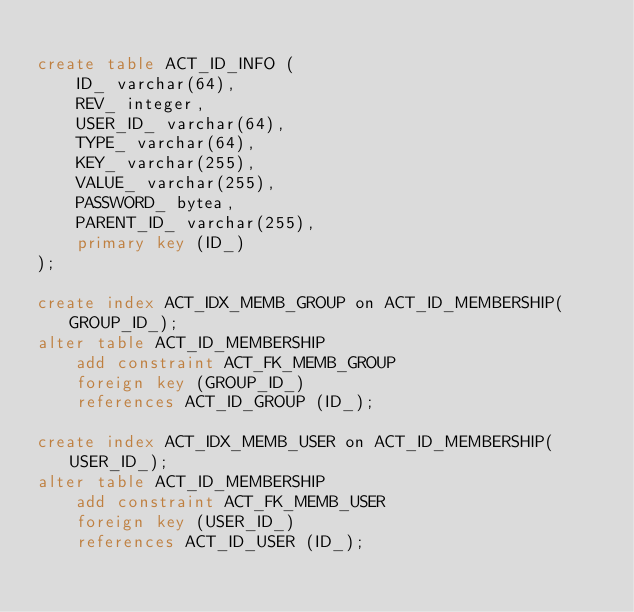Convert code to text. <code><loc_0><loc_0><loc_500><loc_500><_SQL_>
create table ACT_ID_INFO (
    ID_ varchar(64),
    REV_ integer,
    USER_ID_ varchar(64),
    TYPE_ varchar(64),
    KEY_ varchar(255),
    VALUE_ varchar(255),
    PASSWORD_ bytea,
    PARENT_ID_ varchar(255),
    primary key (ID_)
);

create index ACT_IDX_MEMB_GROUP on ACT_ID_MEMBERSHIP(GROUP_ID_);
alter table ACT_ID_MEMBERSHIP 
    add constraint ACT_FK_MEMB_GROUP
    foreign key (GROUP_ID_) 
    references ACT_ID_GROUP (ID_);

create index ACT_IDX_MEMB_USER on ACT_ID_MEMBERSHIP(USER_ID_);
alter table ACT_ID_MEMBERSHIP 
    add constraint ACT_FK_MEMB_USER
    foreign key (USER_ID_) 
    references ACT_ID_USER (ID_);
</code> 